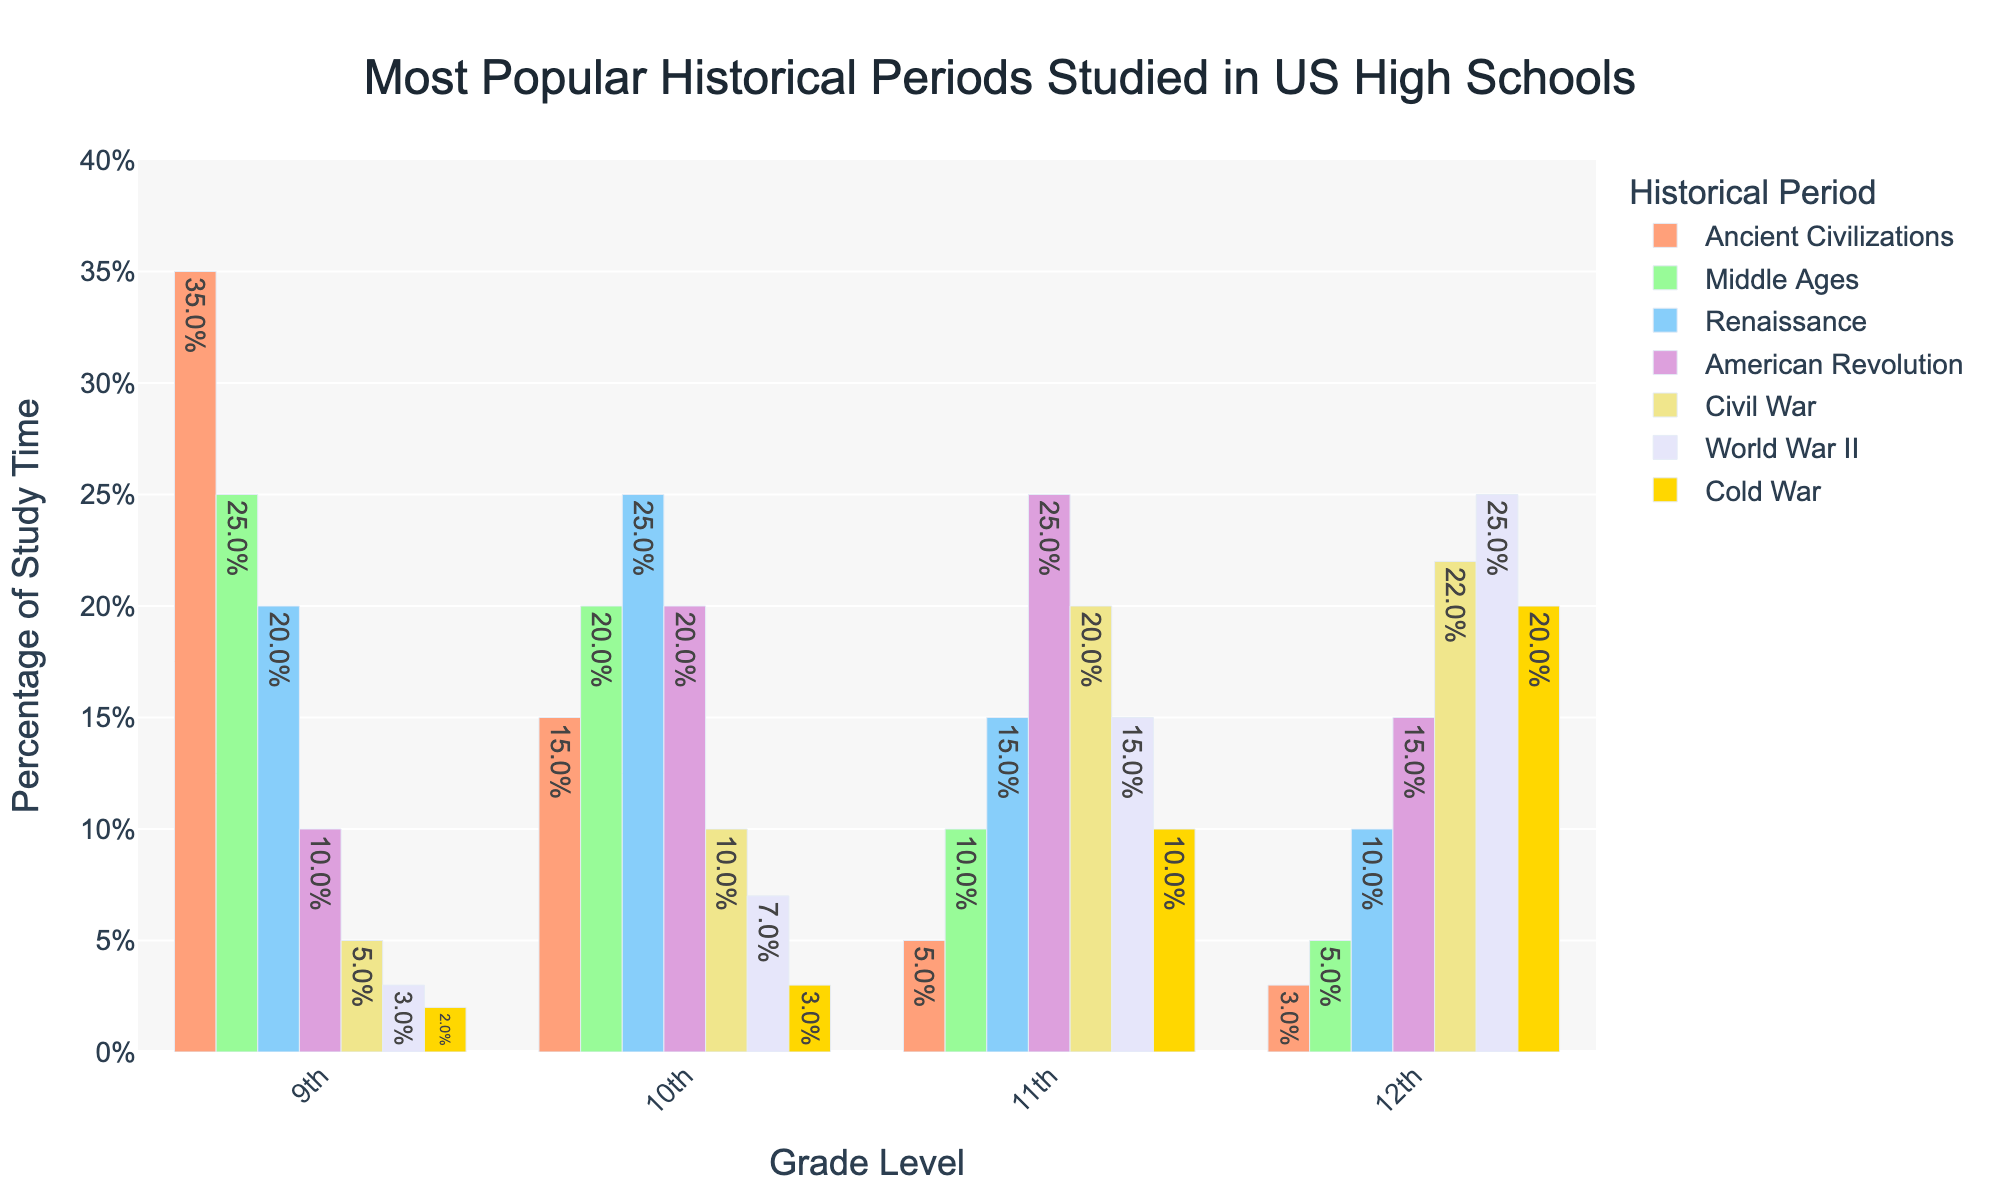How does the percentage of students studying the Renaissance change from 9th grade to 12th grade? To find this out, compare the percentage values related to the Renaissance from 9th grade (20%) to 12th grade (10%).
Answer: It decreases from 20% to 10% Which grade devotes the most study time to Ancient Civilizations? Examine the bars corresponding to Ancient Civilizations for each grade. The 9th grade has the highest bar for this period at 35%.
Answer: 9th grade What is the total percentage of study time devoted to the World War II by students in grades 10, 11, and 12? Sum the percentages of World War II for the 10th (7%), 11th (15%), and 12th (25%) grades. 7% + 15% + 25% = 47%.
Answer: 47% In which grade is the Middle Ages the most popular historical period studied? Look for the highest percentage in the Middle Ages category, which is 25% in the 9th grade.
Answer: 9th grade Which historical period shows the biggest increase in popularity from 9th grade to 12th grade? Compare each period's percentage increase from 9th grade to 12th grade. The Cold War increases from 2% (9th grade) to 20% (12th grade), which is the largest increase.
Answer: Cold War What is the combined percentage of study time for Ancient Civilizations and the American Revolution in 9th grade? Add the percentages for Ancient Civilizations (35%) and the American Revolution (10%) in 9th grade. 35% + 10% = 45%.
Answer: 45% How do the study percentages of the Civil War compare across each grade level? The percentages for the Civil War across each grade are: 9th grade (5%), 10th grade (10%), 11th grade (20%), and 12th grade (22%). Analyze these values to compare them.
Answer: 5%, 10%, 20%, 22% Which grades have a higher percentage of study time dedicated to the Cold War compared to Ancient Civilizations? Compare percentages for the Cold War and Ancient Civilizations in each grade. The Cold War (20%) is higher than Ancient Civilizations (3%) in 12th grade. In other grades, Ancient Civilizations has a higher percentage.
Answer: 12th grade What is the average percentage of study time for the Middle Ages across all grades? Sum the percentages for the Middle Ages across all grades and divide by the number of grades. (25% + 20% + 10% + 5%) / 4 = 15%.
Answer: 15% Which period is least studied by 11th graders? Look for the smallest percentage in 11th grade, which is Ancient Civilizations at 5%.
Answer: Ancient Civilizations 